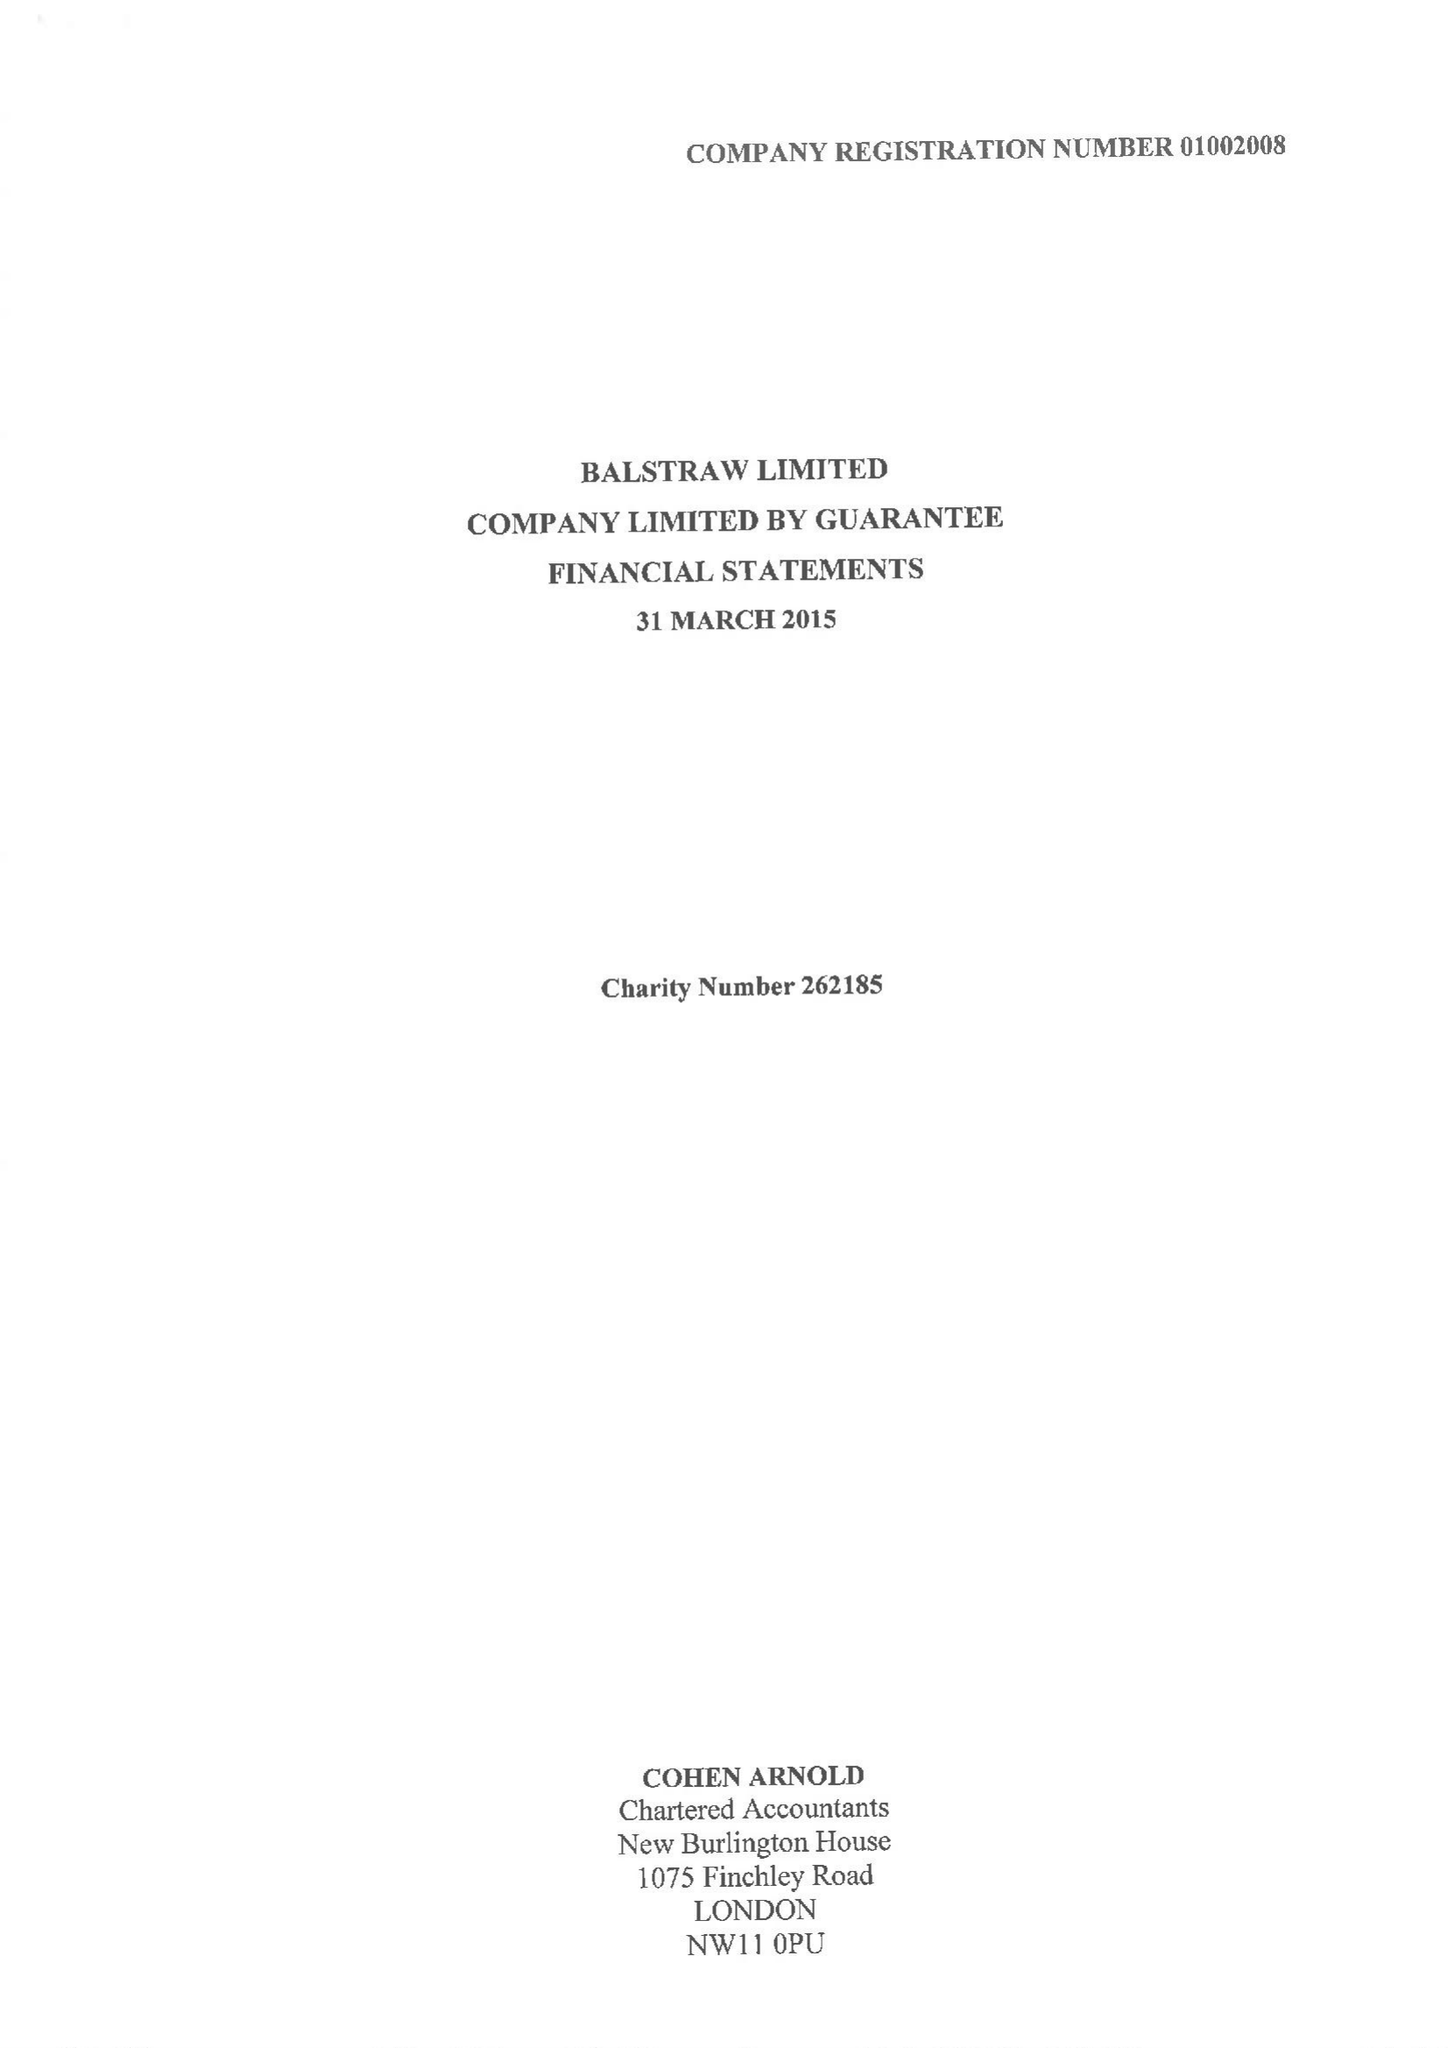What is the value for the address__street_line?
Answer the question using a single word or phrase. 1075 FINCHLEY ROAD 